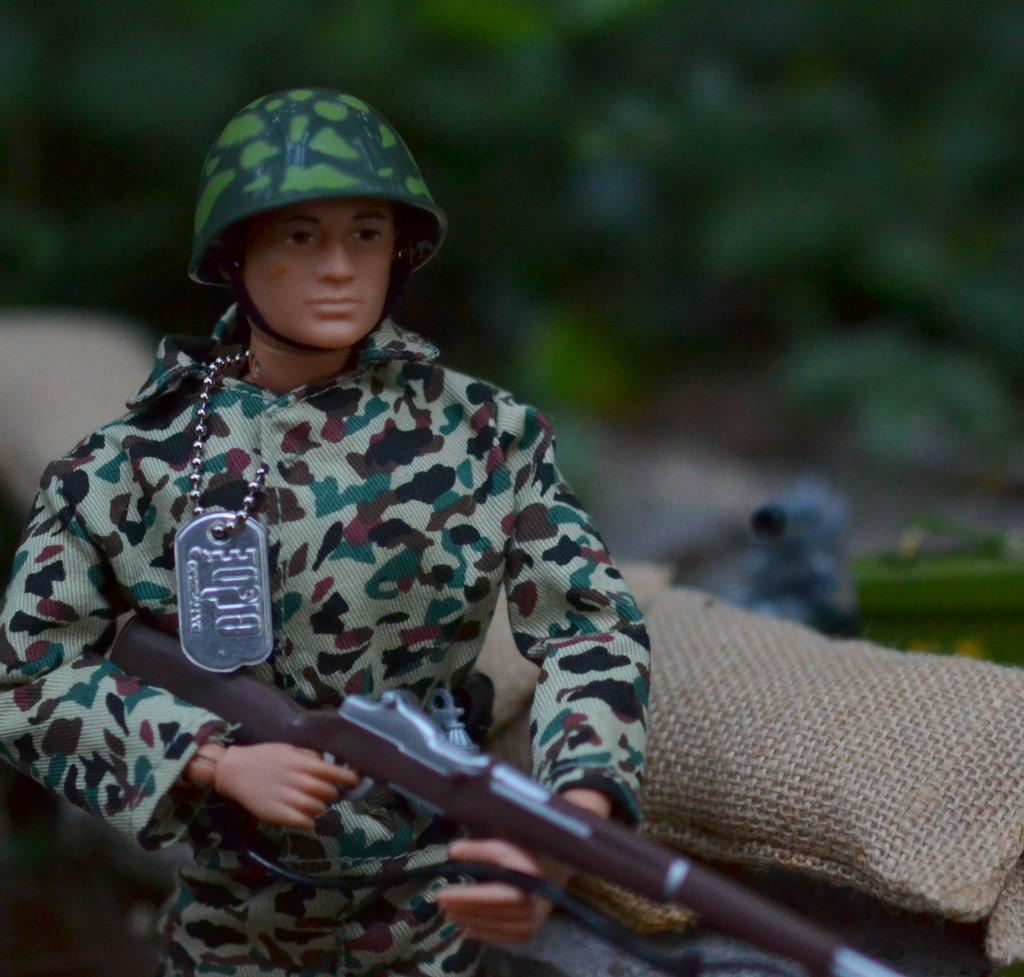What is the main subject of the image? There is a doll in the image. What type of doll is depicted? The doll resembles an army soldier. What can be seen on the right side of the image? There are bags on the right side of the image. What is visible in the background of the image? There are trees in the background of the image. What type of trousers is the brother wearing in the image? There is no brother present in the image, and therefore no trousers to describe. 